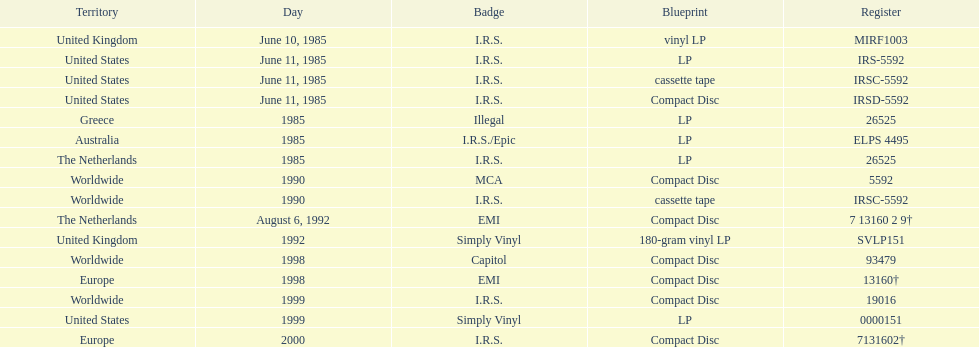What was the date of the initial vinyl lp launch? June 10, 1985. 